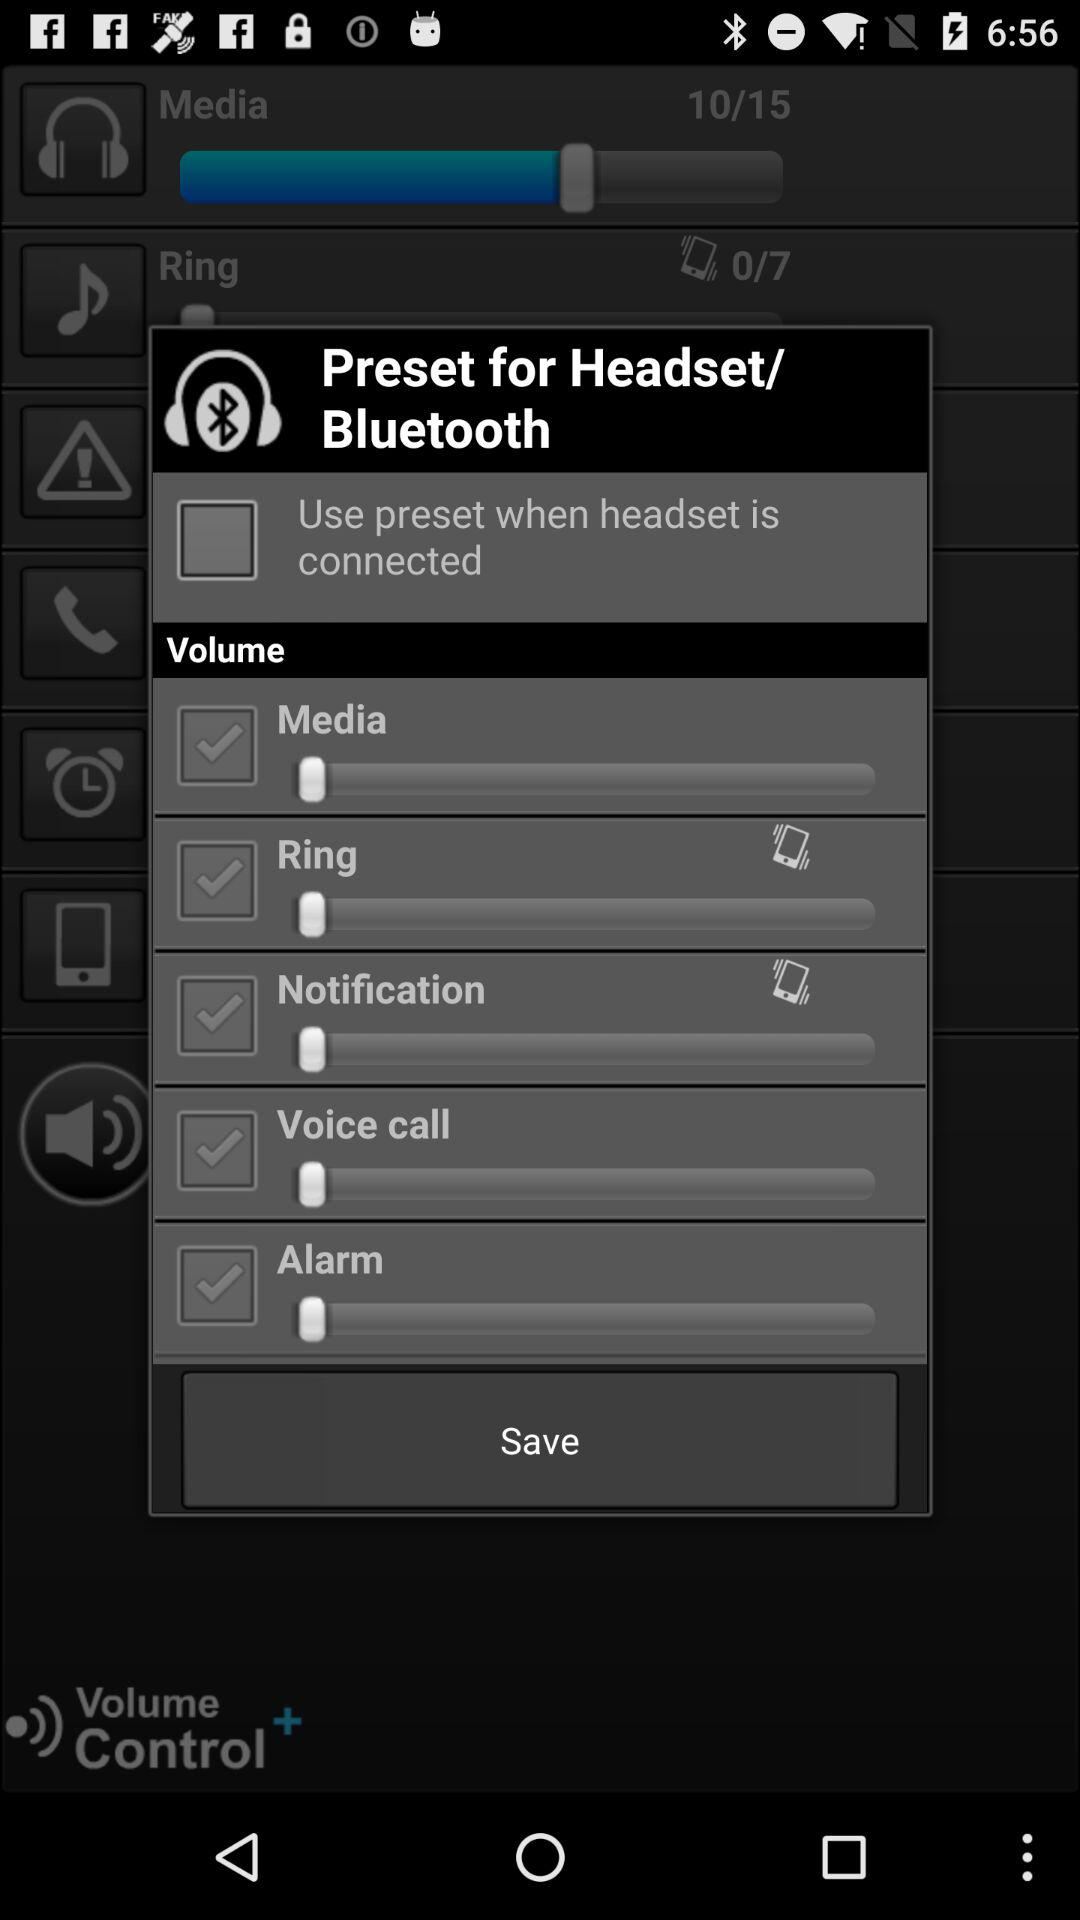What is the status of "Ring Volume"? The status is "on". 